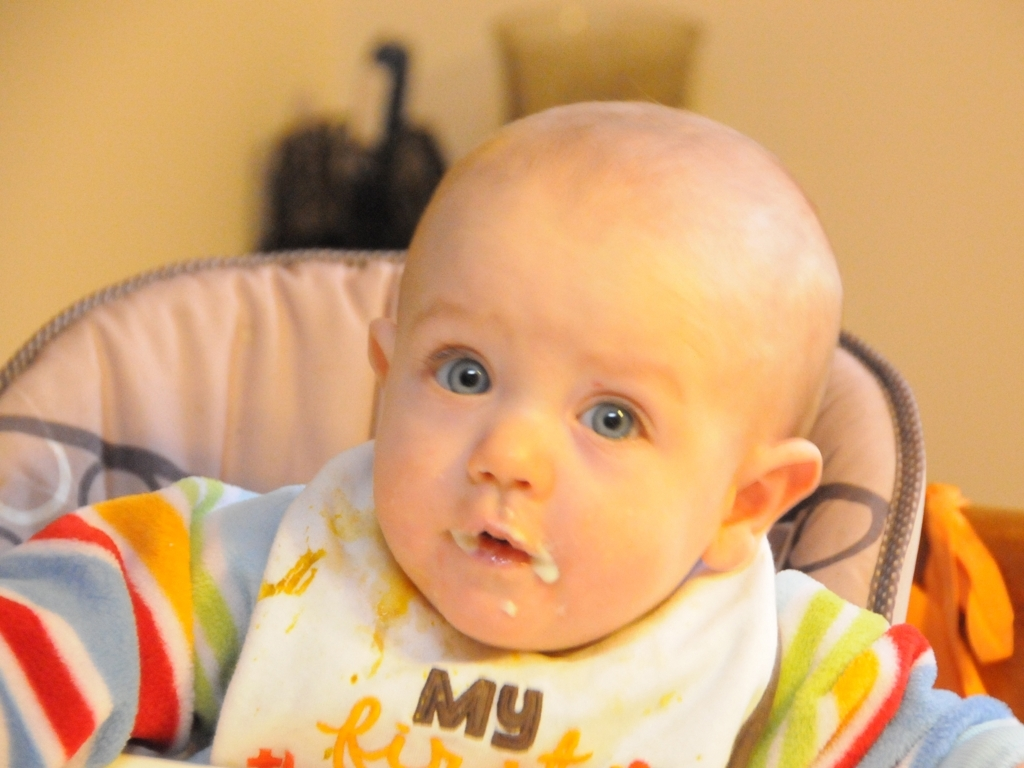Describe the setting where the baby is located. The baby is situated in a high chair, likely in a home environment. There is a soft, indoor lighting setting, and in the background, home furnishings suggest a comfortable family living space. What can you tell about the baby’s mealtime? The baby is wearing a bib with some food stains, indicating it's mealtime. The smudges of food around the mouth point to an independent, though somewhat messy, attempt at eating, which is typical for infants learning to feed themselves. 